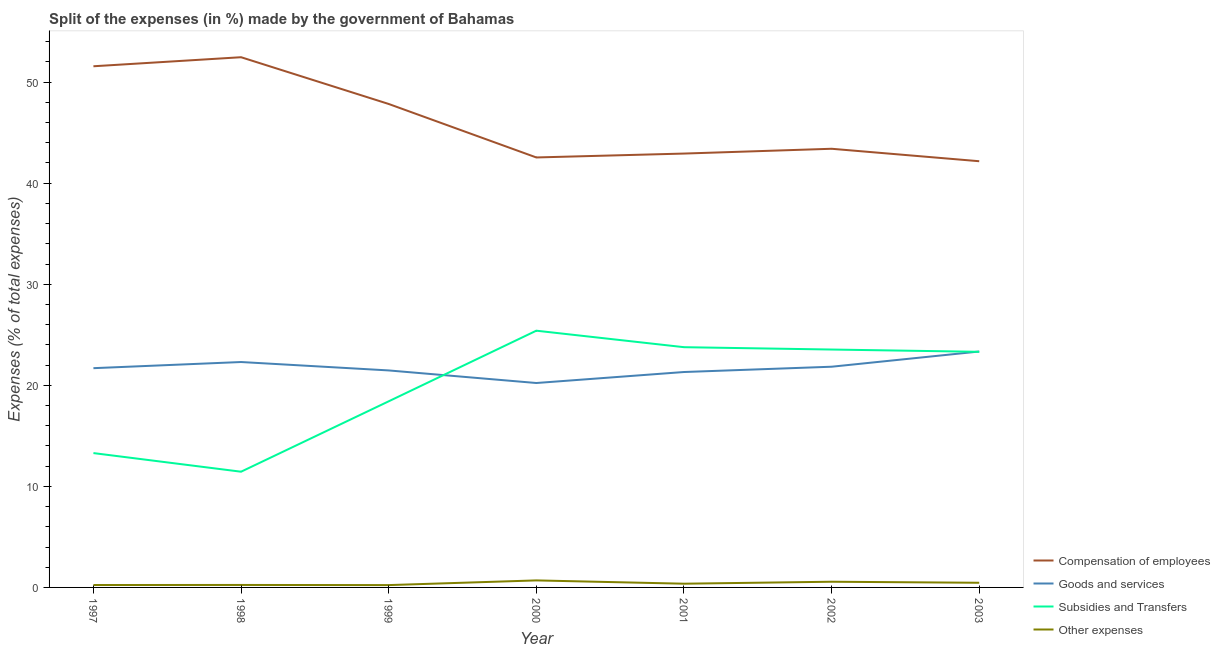Does the line corresponding to percentage of amount spent on goods and services intersect with the line corresponding to percentage of amount spent on compensation of employees?
Your response must be concise. No. Is the number of lines equal to the number of legend labels?
Make the answer very short. Yes. What is the percentage of amount spent on compensation of employees in 2001?
Provide a short and direct response. 42.93. Across all years, what is the maximum percentage of amount spent on other expenses?
Provide a succinct answer. 0.7. Across all years, what is the minimum percentage of amount spent on compensation of employees?
Give a very brief answer. 42.17. In which year was the percentage of amount spent on compensation of employees minimum?
Keep it short and to the point. 2003. What is the total percentage of amount spent on goods and services in the graph?
Keep it short and to the point. 152.19. What is the difference between the percentage of amount spent on goods and services in 1997 and that in 2000?
Provide a succinct answer. 1.47. What is the difference between the percentage of amount spent on goods and services in 2001 and the percentage of amount spent on subsidies in 2003?
Your answer should be very brief. -2. What is the average percentage of amount spent on goods and services per year?
Your answer should be very brief. 21.74. In the year 2002, what is the difference between the percentage of amount spent on compensation of employees and percentage of amount spent on subsidies?
Keep it short and to the point. 19.87. What is the ratio of the percentage of amount spent on goods and services in 1997 to that in 1998?
Offer a terse response. 0.97. Is the percentage of amount spent on compensation of employees in 2001 less than that in 2002?
Your answer should be compact. Yes. What is the difference between the highest and the second highest percentage of amount spent on compensation of employees?
Provide a succinct answer. 0.9. What is the difference between the highest and the lowest percentage of amount spent on goods and services?
Your answer should be very brief. 3.12. In how many years, is the percentage of amount spent on compensation of employees greater than the average percentage of amount spent on compensation of employees taken over all years?
Make the answer very short. 3. Is the sum of the percentage of amount spent on subsidies in 1997 and 1998 greater than the maximum percentage of amount spent on other expenses across all years?
Your answer should be compact. Yes. Is it the case that in every year, the sum of the percentage of amount spent on compensation of employees and percentage of amount spent on goods and services is greater than the percentage of amount spent on subsidies?
Your answer should be very brief. Yes. How many lines are there?
Keep it short and to the point. 4. What is the difference between two consecutive major ticks on the Y-axis?
Give a very brief answer. 10. Does the graph contain any zero values?
Your answer should be compact. No. Does the graph contain grids?
Make the answer very short. No. How many legend labels are there?
Ensure brevity in your answer.  4. How are the legend labels stacked?
Your answer should be very brief. Vertical. What is the title of the graph?
Provide a short and direct response. Split of the expenses (in %) made by the government of Bahamas. What is the label or title of the Y-axis?
Give a very brief answer. Expenses (% of total expenses). What is the Expenses (% of total expenses) in Compensation of employees in 1997?
Keep it short and to the point. 51.57. What is the Expenses (% of total expenses) in Goods and services in 1997?
Make the answer very short. 21.7. What is the Expenses (% of total expenses) of Subsidies and Transfers in 1997?
Your answer should be very brief. 13.29. What is the Expenses (% of total expenses) in Other expenses in 1997?
Provide a short and direct response. 0.24. What is the Expenses (% of total expenses) of Compensation of employees in 1998?
Keep it short and to the point. 52.46. What is the Expenses (% of total expenses) in Goods and services in 1998?
Make the answer very short. 22.3. What is the Expenses (% of total expenses) in Subsidies and Transfers in 1998?
Offer a terse response. 11.45. What is the Expenses (% of total expenses) of Other expenses in 1998?
Keep it short and to the point. 0.25. What is the Expenses (% of total expenses) of Compensation of employees in 1999?
Your answer should be very brief. 47.84. What is the Expenses (% of total expenses) in Goods and services in 1999?
Keep it short and to the point. 21.47. What is the Expenses (% of total expenses) of Subsidies and Transfers in 1999?
Provide a short and direct response. 18.42. What is the Expenses (% of total expenses) in Other expenses in 1999?
Offer a very short reply. 0.23. What is the Expenses (% of total expenses) in Compensation of employees in 2000?
Ensure brevity in your answer.  42.55. What is the Expenses (% of total expenses) in Goods and services in 2000?
Your answer should be compact. 20.23. What is the Expenses (% of total expenses) in Subsidies and Transfers in 2000?
Your answer should be very brief. 25.4. What is the Expenses (% of total expenses) of Other expenses in 2000?
Provide a succinct answer. 0.7. What is the Expenses (% of total expenses) in Compensation of employees in 2001?
Provide a short and direct response. 42.93. What is the Expenses (% of total expenses) in Goods and services in 2001?
Provide a short and direct response. 21.31. What is the Expenses (% of total expenses) in Subsidies and Transfers in 2001?
Your answer should be compact. 23.77. What is the Expenses (% of total expenses) in Other expenses in 2001?
Your answer should be compact. 0.37. What is the Expenses (% of total expenses) of Compensation of employees in 2002?
Provide a short and direct response. 43.41. What is the Expenses (% of total expenses) in Goods and services in 2002?
Your answer should be very brief. 21.84. What is the Expenses (% of total expenses) of Subsidies and Transfers in 2002?
Provide a succinct answer. 23.54. What is the Expenses (% of total expenses) in Other expenses in 2002?
Offer a terse response. 0.56. What is the Expenses (% of total expenses) of Compensation of employees in 2003?
Make the answer very short. 42.17. What is the Expenses (% of total expenses) in Goods and services in 2003?
Offer a terse response. 23.34. What is the Expenses (% of total expenses) in Subsidies and Transfers in 2003?
Your answer should be compact. 23.31. What is the Expenses (% of total expenses) of Other expenses in 2003?
Your response must be concise. 0.46. Across all years, what is the maximum Expenses (% of total expenses) in Compensation of employees?
Your answer should be very brief. 52.46. Across all years, what is the maximum Expenses (% of total expenses) of Goods and services?
Your answer should be compact. 23.34. Across all years, what is the maximum Expenses (% of total expenses) of Subsidies and Transfers?
Provide a short and direct response. 25.4. Across all years, what is the maximum Expenses (% of total expenses) of Other expenses?
Ensure brevity in your answer.  0.7. Across all years, what is the minimum Expenses (% of total expenses) of Compensation of employees?
Offer a terse response. 42.17. Across all years, what is the minimum Expenses (% of total expenses) in Goods and services?
Provide a succinct answer. 20.23. Across all years, what is the minimum Expenses (% of total expenses) of Subsidies and Transfers?
Offer a very short reply. 11.45. Across all years, what is the minimum Expenses (% of total expenses) in Other expenses?
Your answer should be very brief. 0.23. What is the total Expenses (% of total expenses) of Compensation of employees in the graph?
Keep it short and to the point. 322.92. What is the total Expenses (% of total expenses) of Goods and services in the graph?
Make the answer very short. 152.19. What is the total Expenses (% of total expenses) of Subsidies and Transfers in the graph?
Provide a short and direct response. 139.19. What is the total Expenses (% of total expenses) of Other expenses in the graph?
Your answer should be very brief. 2.8. What is the difference between the Expenses (% of total expenses) in Compensation of employees in 1997 and that in 1998?
Provide a short and direct response. -0.9. What is the difference between the Expenses (% of total expenses) in Goods and services in 1997 and that in 1998?
Offer a terse response. -0.61. What is the difference between the Expenses (% of total expenses) in Subsidies and Transfers in 1997 and that in 1998?
Provide a short and direct response. 1.84. What is the difference between the Expenses (% of total expenses) in Other expenses in 1997 and that in 1998?
Your answer should be very brief. -0.01. What is the difference between the Expenses (% of total expenses) in Compensation of employees in 1997 and that in 1999?
Give a very brief answer. 3.73. What is the difference between the Expenses (% of total expenses) of Goods and services in 1997 and that in 1999?
Your response must be concise. 0.22. What is the difference between the Expenses (% of total expenses) in Subsidies and Transfers in 1997 and that in 1999?
Your answer should be compact. -5.12. What is the difference between the Expenses (% of total expenses) of Other expenses in 1997 and that in 1999?
Provide a short and direct response. 0.01. What is the difference between the Expenses (% of total expenses) of Compensation of employees in 1997 and that in 2000?
Offer a terse response. 9.02. What is the difference between the Expenses (% of total expenses) of Goods and services in 1997 and that in 2000?
Your response must be concise. 1.47. What is the difference between the Expenses (% of total expenses) of Subsidies and Transfers in 1997 and that in 2000?
Ensure brevity in your answer.  -12.11. What is the difference between the Expenses (% of total expenses) of Other expenses in 1997 and that in 2000?
Provide a succinct answer. -0.46. What is the difference between the Expenses (% of total expenses) of Compensation of employees in 1997 and that in 2001?
Offer a terse response. 8.64. What is the difference between the Expenses (% of total expenses) in Goods and services in 1997 and that in 2001?
Provide a short and direct response. 0.38. What is the difference between the Expenses (% of total expenses) in Subsidies and Transfers in 1997 and that in 2001?
Make the answer very short. -10.48. What is the difference between the Expenses (% of total expenses) in Other expenses in 1997 and that in 2001?
Make the answer very short. -0.13. What is the difference between the Expenses (% of total expenses) in Compensation of employees in 1997 and that in 2002?
Keep it short and to the point. 8.16. What is the difference between the Expenses (% of total expenses) of Goods and services in 1997 and that in 2002?
Give a very brief answer. -0.14. What is the difference between the Expenses (% of total expenses) in Subsidies and Transfers in 1997 and that in 2002?
Your response must be concise. -10.25. What is the difference between the Expenses (% of total expenses) of Other expenses in 1997 and that in 2002?
Keep it short and to the point. -0.32. What is the difference between the Expenses (% of total expenses) in Compensation of employees in 1997 and that in 2003?
Provide a succinct answer. 9.4. What is the difference between the Expenses (% of total expenses) of Goods and services in 1997 and that in 2003?
Make the answer very short. -1.65. What is the difference between the Expenses (% of total expenses) in Subsidies and Transfers in 1997 and that in 2003?
Provide a succinct answer. -10.02. What is the difference between the Expenses (% of total expenses) in Other expenses in 1997 and that in 2003?
Offer a very short reply. -0.22. What is the difference between the Expenses (% of total expenses) in Compensation of employees in 1998 and that in 1999?
Provide a succinct answer. 4.63. What is the difference between the Expenses (% of total expenses) of Goods and services in 1998 and that in 1999?
Give a very brief answer. 0.83. What is the difference between the Expenses (% of total expenses) of Subsidies and Transfers in 1998 and that in 1999?
Provide a short and direct response. -6.97. What is the difference between the Expenses (% of total expenses) in Other expenses in 1998 and that in 1999?
Provide a short and direct response. 0.01. What is the difference between the Expenses (% of total expenses) in Compensation of employees in 1998 and that in 2000?
Keep it short and to the point. 9.92. What is the difference between the Expenses (% of total expenses) of Goods and services in 1998 and that in 2000?
Keep it short and to the point. 2.08. What is the difference between the Expenses (% of total expenses) of Subsidies and Transfers in 1998 and that in 2000?
Offer a terse response. -13.95. What is the difference between the Expenses (% of total expenses) in Other expenses in 1998 and that in 2000?
Keep it short and to the point. -0.45. What is the difference between the Expenses (% of total expenses) of Compensation of employees in 1998 and that in 2001?
Make the answer very short. 9.53. What is the difference between the Expenses (% of total expenses) in Goods and services in 1998 and that in 2001?
Give a very brief answer. 0.99. What is the difference between the Expenses (% of total expenses) of Subsidies and Transfers in 1998 and that in 2001?
Ensure brevity in your answer.  -12.32. What is the difference between the Expenses (% of total expenses) in Other expenses in 1998 and that in 2001?
Offer a terse response. -0.12. What is the difference between the Expenses (% of total expenses) of Compensation of employees in 1998 and that in 2002?
Give a very brief answer. 9.06. What is the difference between the Expenses (% of total expenses) of Goods and services in 1998 and that in 2002?
Offer a terse response. 0.47. What is the difference between the Expenses (% of total expenses) in Subsidies and Transfers in 1998 and that in 2002?
Your answer should be very brief. -12.09. What is the difference between the Expenses (% of total expenses) of Other expenses in 1998 and that in 2002?
Ensure brevity in your answer.  -0.32. What is the difference between the Expenses (% of total expenses) of Compensation of employees in 1998 and that in 2003?
Your response must be concise. 10.29. What is the difference between the Expenses (% of total expenses) in Goods and services in 1998 and that in 2003?
Offer a very short reply. -1.04. What is the difference between the Expenses (% of total expenses) of Subsidies and Transfers in 1998 and that in 2003?
Your answer should be very brief. -11.86. What is the difference between the Expenses (% of total expenses) of Other expenses in 1998 and that in 2003?
Keep it short and to the point. -0.22. What is the difference between the Expenses (% of total expenses) of Compensation of employees in 1999 and that in 2000?
Your response must be concise. 5.29. What is the difference between the Expenses (% of total expenses) of Goods and services in 1999 and that in 2000?
Make the answer very short. 1.24. What is the difference between the Expenses (% of total expenses) of Subsidies and Transfers in 1999 and that in 2000?
Your response must be concise. -6.99. What is the difference between the Expenses (% of total expenses) in Other expenses in 1999 and that in 2000?
Provide a succinct answer. -0.46. What is the difference between the Expenses (% of total expenses) of Compensation of employees in 1999 and that in 2001?
Your answer should be compact. 4.91. What is the difference between the Expenses (% of total expenses) of Goods and services in 1999 and that in 2001?
Offer a terse response. 0.16. What is the difference between the Expenses (% of total expenses) of Subsidies and Transfers in 1999 and that in 2001?
Provide a succinct answer. -5.36. What is the difference between the Expenses (% of total expenses) in Other expenses in 1999 and that in 2001?
Ensure brevity in your answer.  -0.14. What is the difference between the Expenses (% of total expenses) in Compensation of employees in 1999 and that in 2002?
Your answer should be very brief. 4.43. What is the difference between the Expenses (% of total expenses) in Goods and services in 1999 and that in 2002?
Provide a succinct answer. -0.37. What is the difference between the Expenses (% of total expenses) in Subsidies and Transfers in 1999 and that in 2002?
Offer a very short reply. -5.12. What is the difference between the Expenses (% of total expenses) in Other expenses in 1999 and that in 2002?
Ensure brevity in your answer.  -0.33. What is the difference between the Expenses (% of total expenses) in Compensation of employees in 1999 and that in 2003?
Keep it short and to the point. 5.67. What is the difference between the Expenses (% of total expenses) in Goods and services in 1999 and that in 2003?
Give a very brief answer. -1.87. What is the difference between the Expenses (% of total expenses) of Subsidies and Transfers in 1999 and that in 2003?
Give a very brief answer. -4.9. What is the difference between the Expenses (% of total expenses) of Other expenses in 1999 and that in 2003?
Keep it short and to the point. -0.23. What is the difference between the Expenses (% of total expenses) in Compensation of employees in 2000 and that in 2001?
Make the answer very short. -0.38. What is the difference between the Expenses (% of total expenses) in Goods and services in 2000 and that in 2001?
Keep it short and to the point. -1.09. What is the difference between the Expenses (% of total expenses) in Subsidies and Transfers in 2000 and that in 2001?
Your answer should be compact. 1.63. What is the difference between the Expenses (% of total expenses) of Other expenses in 2000 and that in 2001?
Keep it short and to the point. 0.33. What is the difference between the Expenses (% of total expenses) in Compensation of employees in 2000 and that in 2002?
Your answer should be very brief. -0.86. What is the difference between the Expenses (% of total expenses) in Goods and services in 2000 and that in 2002?
Your response must be concise. -1.61. What is the difference between the Expenses (% of total expenses) of Subsidies and Transfers in 2000 and that in 2002?
Provide a succinct answer. 1.86. What is the difference between the Expenses (% of total expenses) in Other expenses in 2000 and that in 2002?
Make the answer very short. 0.13. What is the difference between the Expenses (% of total expenses) of Compensation of employees in 2000 and that in 2003?
Your answer should be very brief. 0.37. What is the difference between the Expenses (% of total expenses) of Goods and services in 2000 and that in 2003?
Give a very brief answer. -3.12. What is the difference between the Expenses (% of total expenses) of Subsidies and Transfers in 2000 and that in 2003?
Provide a succinct answer. 2.09. What is the difference between the Expenses (% of total expenses) of Other expenses in 2000 and that in 2003?
Give a very brief answer. 0.23. What is the difference between the Expenses (% of total expenses) in Compensation of employees in 2001 and that in 2002?
Your response must be concise. -0.48. What is the difference between the Expenses (% of total expenses) of Goods and services in 2001 and that in 2002?
Keep it short and to the point. -0.52. What is the difference between the Expenses (% of total expenses) in Subsidies and Transfers in 2001 and that in 2002?
Give a very brief answer. 0.23. What is the difference between the Expenses (% of total expenses) of Other expenses in 2001 and that in 2002?
Your answer should be compact. -0.19. What is the difference between the Expenses (% of total expenses) of Compensation of employees in 2001 and that in 2003?
Your answer should be compact. 0.76. What is the difference between the Expenses (% of total expenses) of Goods and services in 2001 and that in 2003?
Your response must be concise. -2.03. What is the difference between the Expenses (% of total expenses) in Subsidies and Transfers in 2001 and that in 2003?
Ensure brevity in your answer.  0.46. What is the difference between the Expenses (% of total expenses) of Other expenses in 2001 and that in 2003?
Give a very brief answer. -0.09. What is the difference between the Expenses (% of total expenses) in Compensation of employees in 2002 and that in 2003?
Keep it short and to the point. 1.23. What is the difference between the Expenses (% of total expenses) of Goods and services in 2002 and that in 2003?
Give a very brief answer. -1.51. What is the difference between the Expenses (% of total expenses) of Subsidies and Transfers in 2002 and that in 2003?
Make the answer very short. 0.23. What is the difference between the Expenses (% of total expenses) in Other expenses in 2002 and that in 2003?
Provide a short and direct response. 0.1. What is the difference between the Expenses (% of total expenses) in Compensation of employees in 1997 and the Expenses (% of total expenses) in Goods and services in 1998?
Offer a very short reply. 29.26. What is the difference between the Expenses (% of total expenses) in Compensation of employees in 1997 and the Expenses (% of total expenses) in Subsidies and Transfers in 1998?
Ensure brevity in your answer.  40.12. What is the difference between the Expenses (% of total expenses) of Compensation of employees in 1997 and the Expenses (% of total expenses) of Other expenses in 1998?
Your answer should be compact. 51.32. What is the difference between the Expenses (% of total expenses) of Goods and services in 1997 and the Expenses (% of total expenses) of Subsidies and Transfers in 1998?
Keep it short and to the point. 10.24. What is the difference between the Expenses (% of total expenses) of Goods and services in 1997 and the Expenses (% of total expenses) of Other expenses in 1998?
Your answer should be very brief. 21.45. What is the difference between the Expenses (% of total expenses) of Subsidies and Transfers in 1997 and the Expenses (% of total expenses) of Other expenses in 1998?
Offer a very short reply. 13.05. What is the difference between the Expenses (% of total expenses) in Compensation of employees in 1997 and the Expenses (% of total expenses) in Goods and services in 1999?
Keep it short and to the point. 30.1. What is the difference between the Expenses (% of total expenses) of Compensation of employees in 1997 and the Expenses (% of total expenses) of Subsidies and Transfers in 1999?
Ensure brevity in your answer.  33.15. What is the difference between the Expenses (% of total expenses) of Compensation of employees in 1997 and the Expenses (% of total expenses) of Other expenses in 1999?
Ensure brevity in your answer.  51.34. What is the difference between the Expenses (% of total expenses) of Goods and services in 1997 and the Expenses (% of total expenses) of Subsidies and Transfers in 1999?
Offer a very short reply. 3.28. What is the difference between the Expenses (% of total expenses) of Goods and services in 1997 and the Expenses (% of total expenses) of Other expenses in 1999?
Ensure brevity in your answer.  21.46. What is the difference between the Expenses (% of total expenses) of Subsidies and Transfers in 1997 and the Expenses (% of total expenses) of Other expenses in 1999?
Your answer should be very brief. 13.06. What is the difference between the Expenses (% of total expenses) of Compensation of employees in 1997 and the Expenses (% of total expenses) of Goods and services in 2000?
Your answer should be very brief. 31.34. What is the difference between the Expenses (% of total expenses) in Compensation of employees in 1997 and the Expenses (% of total expenses) in Subsidies and Transfers in 2000?
Keep it short and to the point. 26.16. What is the difference between the Expenses (% of total expenses) of Compensation of employees in 1997 and the Expenses (% of total expenses) of Other expenses in 2000?
Keep it short and to the point. 50.87. What is the difference between the Expenses (% of total expenses) of Goods and services in 1997 and the Expenses (% of total expenses) of Subsidies and Transfers in 2000?
Offer a terse response. -3.71. What is the difference between the Expenses (% of total expenses) of Goods and services in 1997 and the Expenses (% of total expenses) of Other expenses in 2000?
Your answer should be compact. 21. What is the difference between the Expenses (% of total expenses) in Subsidies and Transfers in 1997 and the Expenses (% of total expenses) in Other expenses in 2000?
Keep it short and to the point. 12.6. What is the difference between the Expenses (% of total expenses) in Compensation of employees in 1997 and the Expenses (% of total expenses) in Goods and services in 2001?
Your answer should be compact. 30.25. What is the difference between the Expenses (% of total expenses) in Compensation of employees in 1997 and the Expenses (% of total expenses) in Subsidies and Transfers in 2001?
Offer a very short reply. 27.8. What is the difference between the Expenses (% of total expenses) in Compensation of employees in 1997 and the Expenses (% of total expenses) in Other expenses in 2001?
Provide a succinct answer. 51.2. What is the difference between the Expenses (% of total expenses) in Goods and services in 1997 and the Expenses (% of total expenses) in Subsidies and Transfers in 2001?
Give a very brief answer. -2.08. What is the difference between the Expenses (% of total expenses) of Goods and services in 1997 and the Expenses (% of total expenses) of Other expenses in 2001?
Provide a short and direct response. 21.33. What is the difference between the Expenses (% of total expenses) of Subsidies and Transfers in 1997 and the Expenses (% of total expenses) of Other expenses in 2001?
Your response must be concise. 12.92. What is the difference between the Expenses (% of total expenses) in Compensation of employees in 1997 and the Expenses (% of total expenses) in Goods and services in 2002?
Your answer should be compact. 29.73. What is the difference between the Expenses (% of total expenses) of Compensation of employees in 1997 and the Expenses (% of total expenses) of Subsidies and Transfers in 2002?
Your answer should be very brief. 28.03. What is the difference between the Expenses (% of total expenses) in Compensation of employees in 1997 and the Expenses (% of total expenses) in Other expenses in 2002?
Give a very brief answer. 51. What is the difference between the Expenses (% of total expenses) of Goods and services in 1997 and the Expenses (% of total expenses) of Subsidies and Transfers in 2002?
Your answer should be compact. -1.84. What is the difference between the Expenses (% of total expenses) of Goods and services in 1997 and the Expenses (% of total expenses) of Other expenses in 2002?
Offer a very short reply. 21.13. What is the difference between the Expenses (% of total expenses) in Subsidies and Transfers in 1997 and the Expenses (% of total expenses) in Other expenses in 2002?
Ensure brevity in your answer.  12.73. What is the difference between the Expenses (% of total expenses) of Compensation of employees in 1997 and the Expenses (% of total expenses) of Goods and services in 2003?
Offer a very short reply. 28.22. What is the difference between the Expenses (% of total expenses) in Compensation of employees in 1997 and the Expenses (% of total expenses) in Subsidies and Transfers in 2003?
Your answer should be very brief. 28.25. What is the difference between the Expenses (% of total expenses) in Compensation of employees in 1997 and the Expenses (% of total expenses) in Other expenses in 2003?
Offer a terse response. 51.11. What is the difference between the Expenses (% of total expenses) in Goods and services in 1997 and the Expenses (% of total expenses) in Subsidies and Transfers in 2003?
Keep it short and to the point. -1.62. What is the difference between the Expenses (% of total expenses) of Goods and services in 1997 and the Expenses (% of total expenses) of Other expenses in 2003?
Your response must be concise. 21.23. What is the difference between the Expenses (% of total expenses) in Subsidies and Transfers in 1997 and the Expenses (% of total expenses) in Other expenses in 2003?
Provide a short and direct response. 12.83. What is the difference between the Expenses (% of total expenses) of Compensation of employees in 1998 and the Expenses (% of total expenses) of Goods and services in 1999?
Keep it short and to the point. 30.99. What is the difference between the Expenses (% of total expenses) in Compensation of employees in 1998 and the Expenses (% of total expenses) in Subsidies and Transfers in 1999?
Your answer should be compact. 34.05. What is the difference between the Expenses (% of total expenses) in Compensation of employees in 1998 and the Expenses (% of total expenses) in Other expenses in 1999?
Offer a terse response. 52.23. What is the difference between the Expenses (% of total expenses) of Goods and services in 1998 and the Expenses (% of total expenses) of Subsidies and Transfers in 1999?
Keep it short and to the point. 3.89. What is the difference between the Expenses (% of total expenses) of Goods and services in 1998 and the Expenses (% of total expenses) of Other expenses in 1999?
Give a very brief answer. 22.07. What is the difference between the Expenses (% of total expenses) of Subsidies and Transfers in 1998 and the Expenses (% of total expenses) of Other expenses in 1999?
Ensure brevity in your answer.  11.22. What is the difference between the Expenses (% of total expenses) in Compensation of employees in 1998 and the Expenses (% of total expenses) in Goods and services in 2000?
Provide a succinct answer. 32.24. What is the difference between the Expenses (% of total expenses) of Compensation of employees in 1998 and the Expenses (% of total expenses) of Subsidies and Transfers in 2000?
Offer a very short reply. 27.06. What is the difference between the Expenses (% of total expenses) in Compensation of employees in 1998 and the Expenses (% of total expenses) in Other expenses in 2000?
Your response must be concise. 51.77. What is the difference between the Expenses (% of total expenses) in Goods and services in 1998 and the Expenses (% of total expenses) in Subsidies and Transfers in 2000?
Keep it short and to the point. -3.1. What is the difference between the Expenses (% of total expenses) in Goods and services in 1998 and the Expenses (% of total expenses) in Other expenses in 2000?
Ensure brevity in your answer.  21.61. What is the difference between the Expenses (% of total expenses) of Subsidies and Transfers in 1998 and the Expenses (% of total expenses) of Other expenses in 2000?
Your answer should be compact. 10.76. What is the difference between the Expenses (% of total expenses) of Compensation of employees in 1998 and the Expenses (% of total expenses) of Goods and services in 2001?
Ensure brevity in your answer.  31.15. What is the difference between the Expenses (% of total expenses) in Compensation of employees in 1998 and the Expenses (% of total expenses) in Subsidies and Transfers in 2001?
Give a very brief answer. 28.69. What is the difference between the Expenses (% of total expenses) of Compensation of employees in 1998 and the Expenses (% of total expenses) of Other expenses in 2001?
Offer a terse response. 52.09. What is the difference between the Expenses (% of total expenses) of Goods and services in 1998 and the Expenses (% of total expenses) of Subsidies and Transfers in 2001?
Offer a terse response. -1.47. What is the difference between the Expenses (% of total expenses) in Goods and services in 1998 and the Expenses (% of total expenses) in Other expenses in 2001?
Keep it short and to the point. 21.93. What is the difference between the Expenses (% of total expenses) of Subsidies and Transfers in 1998 and the Expenses (% of total expenses) of Other expenses in 2001?
Give a very brief answer. 11.08. What is the difference between the Expenses (% of total expenses) in Compensation of employees in 1998 and the Expenses (% of total expenses) in Goods and services in 2002?
Keep it short and to the point. 30.63. What is the difference between the Expenses (% of total expenses) of Compensation of employees in 1998 and the Expenses (% of total expenses) of Subsidies and Transfers in 2002?
Offer a very short reply. 28.92. What is the difference between the Expenses (% of total expenses) of Compensation of employees in 1998 and the Expenses (% of total expenses) of Other expenses in 2002?
Your answer should be very brief. 51.9. What is the difference between the Expenses (% of total expenses) of Goods and services in 1998 and the Expenses (% of total expenses) of Subsidies and Transfers in 2002?
Make the answer very short. -1.24. What is the difference between the Expenses (% of total expenses) of Goods and services in 1998 and the Expenses (% of total expenses) of Other expenses in 2002?
Offer a very short reply. 21.74. What is the difference between the Expenses (% of total expenses) in Subsidies and Transfers in 1998 and the Expenses (% of total expenses) in Other expenses in 2002?
Your answer should be compact. 10.89. What is the difference between the Expenses (% of total expenses) in Compensation of employees in 1998 and the Expenses (% of total expenses) in Goods and services in 2003?
Make the answer very short. 29.12. What is the difference between the Expenses (% of total expenses) of Compensation of employees in 1998 and the Expenses (% of total expenses) of Subsidies and Transfers in 2003?
Your answer should be very brief. 29.15. What is the difference between the Expenses (% of total expenses) of Compensation of employees in 1998 and the Expenses (% of total expenses) of Other expenses in 2003?
Provide a short and direct response. 52. What is the difference between the Expenses (% of total expenses) of Goods and services in 1998 and the Expenses (% of total expenses) of Subsidies and Transfers in 2003?
Provide a short and direct response. -1.01. What is the difference between the Expenses (% of total expenses) in Goods and services in 1998 and the Expenses (% of total expenses) in Other expenses in 2003?
Ensure brevity in your answer.  21.84. What is the difference between the Expenses (% of total expenses) in Subsidies and Transfers in 1998 and the Expenses (% of total expenses) in Other expenses in 2003?
Keep it short and to the point. 10.99. What is the difference between the Expenses (% of total expenses) of Compensation of employees in 1999 and the Expenses (% of total expenses) of Goods and services in 2000?
Keep it short and to the point. 27.61. What is the difference between the Expenses (% of total expenses) in Compensation of employees in 1999 and the Expenses (% of total expenses) in Subsidies and Transfers in 2000?
Offer a terse response. 22.43. What is the difference between the Expenses (% of total expenses) of Compensation of employees in 1999 and the Expenses (% of total expenses) of Other expenses in 2000?
Offer a terse response. 47.14. What is the difference between the Expenses (% of total expenses) in Goods and services in 1999 and the Expenses (% of total expenses) in Subsidies and Transfers in 2000?
Your answer should be very brief. -3.93. What is the difference between the Expenses (% of total expenses) in Goods and services in 1999 and the Expenses (% of total expenses) in Other expenses in 2000?
Your answer should be very brief. 20.78. What is the difference between the Expenses (% of total expenses) of Subsidies and Transfers in 1999 and the Expenses (% of total expenses) of Other expenses in 2000?
Ensure brevity in your answer.  17.72. What is the difference between the Expenses (% of total expenses) in Compensation of employees in 1999 and the Expenses (% of total expenses) in Goods and services in 2001?
Provide a short and direct response. 26.52. What is the difference between the Expenses (% of total expenses) of Compensation of employees in 1999 and the Expenses (% of total expenses) of Subsidies and Transfers in 2001?
Keep it short and to the point. 24.07. What is the difference between the Expenses (% of total expenses) of Compensation of employees in 1999 and the Expenses (% of total expenses) of Other expenses in 2001?
Your answer should be compact. 47.47. What is the difference between the Expenses (% of total expenses) in Goods and services in 1999 and the Expenses (% of total expenses) in Subsidies and Transfers in 2001?
Give a very brief answer. -2.3. What is the difference between the Expenses (% of total expenses) of Goods and services in 1999 and the Expenses (% of total expenses) of Other expenses in 2001?
Offer a terse response. 21.1. What is the difference between the Expenses (% of total expenses) in Subsidies and Transfers in 1999 and the Expenses (% of total expenses) in Other expenses in 2001?
Offer a very short reply. 18.05. What is the difference between the Expenses (% of total expenses) in Compensation of employees in 1999 and the Expenses (% of total expenses) in Goods and services in 2002?
Your response must be concise. 26. What is the difference between the Expenses (% of total expenses) of Compensation of employees in 1999 and the Expenses (% of total expenses) of Subsidies and Transfers in 2002?
Your response must be concise. 24.3. What is the difference between the Expenses (% of total expenses) in Compensation of employees in 1999 and the Expenses (% of total expenses) in Other expenses in 2002?
Offer a very short reply. 47.27. What is the difference between the Expenses (% of total expenses) in Goods and services in 1999 and the Expenses (% of total expenses) in Subsidies and Transfers in 2002?
Make the answer very short. -2.07. What is the difference between the Expenses (% of total expenses) in Goods and services in 1999 and the Expenses (% of total expenses) in Other expenses in 2002?
Offer a very short reply. 20.91. What is the difference between the Expenses (% of total expenses) of Subsidies and Transfers in 1999 and the Expenses (% of total expenses) of Other expenses in 2002?
Make the answer very short. 17.85. What is the difference between the Expenses (% of total expenses) in Compensation of employees in 1999 and the Expenses (% of total expenses) in Goods and services in 2003?
Provide a short and direct response. 24.49. What is the difference between the Expenses (% of total expenses) in Compensation of employees in 1999 and the Expenses (% of total expenses) in Subsidies and Transfers in 2003?
Give a very brief answer. 24.52. What is the difference between the Expenses (% of total expenses) of Compensation of employees in 1999 and the Expenses (% of total expenses) of Other expenses in 2003?
Keep it short and to the point. 47.38. What is the difference between the Expenses (% of total expenses) in Goods and services in 1999 and the Expenses (% of total expenses) in Subsidies and Transfers in 2003?
Ensure brevity in your answer.  -1.84. What is the difference between the Expenses (% of total expenses) of Goods and services in 1999 and the Expenses (% of total expenses) of Other expenses in 2003?
Keep it short and to the point. 21.01. What is the difference between the Expenses (% of total expenses) in Subsidies and Transfers in 1999 and the Expenses (% of total expenses) in Other expenses in 2003?
Give a very brief answer. 17.96. What is the difference between the Expenses (% of total expenses) of Compensation of employees in 2000 and the Expenses (% of total expenses) of Goods and services in 2001?
Your answer should be very brief. 21.23. What is the difference between the Expenses (% of total expenses) of Compensation of employees in 2000 and the Expenses (% of total expenses) of Subsidies and Transfers in 2001?
Offer a very short reply. 18.77. What is the difference between the Expenses (% of total expenses) of Compensation of employees in 2000 and the Expenses (% of total expenses) of Other expenses in 2001?
Keep it short and to the point. 42.18. What is the difference between the Expenses (% of total expenses) in Goods and services in 2000 and the Expenses (% of total expenses) in Subsidies and Transfers in 2001?
Your answer should be very brief. -3.54. What is the difference between the Expenses (% of total expenses) of Goods and services in 2000 and the Expenses (% of total expenses) of Other expenses in 2001?
Offer a terse response. 19.86. What is the difference between the Expenses (% of total expenses) of Subsidies and Transfers in 2000 and the Expenses (% of total expenses) of Other expenses in 2001?
Give a very brief answer. 25.03. What is the difference between the Expenses (% of total expenses) in Compensation of employees in 2000 and the Expenses (% of total expenses) in Goods and services in 2002?
Provide a succinct answer. 20.71. What is the difference between the Expenses (% of total expenses) of Compensation of employees in 2000 and the Expenses (% of total expenses) of Subsidies and Transfers in 2002?
Offer a very short reply. 19.01. What is the difference between the Expenses (% of total expenses) in Compensation of employees in 2000 and the Expenses (% of total expenses) in Other expenses in 2002?
Your answer should be very brief. 41.98. What is the difference between the Expenses (% of total expenses) in Goods and services in 2000 and the Expenses (% of total expenses) in Subsidies and Transfers in 2002?
Your response must be concise. -3.31. What is the difference between the Expenses (% of total expenses) in Goods and services in 2000 and the Expenses (% of total expenses) in Other expenses in 2002?
Your answer should be compact. 19.66. What is the difference between the Expenses (% of total expenses) of Subsidies and Transfers in 2000 and the Expenses (% of total expenses) of Other expenses in 2002?
Provide a succinct answer. 24.84. What is the difference between the Expenses (% of total expenses) in Compensation of employees in 2000 and the Expenses (% of total expenses) in Goods and services in 2003?
Provide a succinct answer. 19.2. What is the difference between the Expenses (% of total expenses) of Compensation of employees in 2000 and the Expenses (% of total expenses) of Subsidies and Transfers in 2003?
Make the answer very short. 19.23. What is the difference between the Expenses (% of total expenses) in Compensation of employees in 2000 and the Expenses (% of total expenses) in Other expenses in 2003?
Your response must be concise. 42.08. What is the difference between the Expenses (% of total expenses) of Goods and services in 2000 and the Expenses (% of total expenses) of Subsidies and Transfers in 2003?
Provide a succinct answer. -3.09. What is the difference between the Expenses (% of total expenses) in Goods and services in 2000 and the Expenses (% of total expenses) in Other expenses in 2003?
Make the answer very short. 19.77. What is the difference between the Expenses (% of total expenses) of Subsidies and Transfers in 2000 and the Expenses (% of total expenses) of Other expenses in 2003?
Your response must be concise. 24.94. What is the difference between the Expenses (% of total expenses) of Compensation of employees in 2001 and the Expenses (% of total expenses) of Goods and services in 2002?
Provide a succinct answer. 21.09. What is the difference between the Expenses (% of total expenses) in Compensation of employees in 2001 and the Expenses (% of total expenses) in Subsidies and Transfers in 2002?
Keep it short and to the point. 19.39. What is the difference between the Expenses (% of total expenses) in Compensation of employees in 2001 and the Expenses (% of total expenses) in Other expenses in 2002?
Offer a terse response. 42.37. What is the difference between the Expenses (% of total expenses) of Goods and services in 2001 and the Expenses (% of total expenses) of Subsidies and Transfers in 2002?
Keep it short and to the point. -2.22. What is the difference between the Expenses (% of total expenses) of Goods and services in 2001 and the Expenses (% of total expenses) of Other expenses in 2002?
Make the answer very short. 20.75. What is the difference between the Expenses (% of total expenses) of Subsidies and Transfers in 2001 and the Expenses (% of total expenses) of Other expenses in 2002?
Offer a terse response. 23.21. What is the difference between the Expenses (% of total expenses) in Compensation of employees in 2001 and the Expenses (% of total expenses) in Goods and services in 2003?
Offer a very short reply. 19.59. What is the difference between the Expenses (% of total expenses) in Compensation of employees in 2001 and the Expenses (% of total expenses) in Subsidies and Transfers in 2003?
Keep it short and to the point. 19.62. What is the difference between the Expenses (% of total expenses) in Compensation of employees in 2001 and the Expenses (% of total expenses) in Other expenses in 2003?
Your response must be concise. 42.47. What is the difference between the Expenses (% of total expenses) of Goods and services in 2001 and the Expenses (% of total expenses) of Subsidies and Transfers in 2003?
Offer a very short reply. -2. What is the difference between the Expenses (% of total expenses) in Goods and services in 2001 and the Expenses (% of total expenses) in Other expenses in 2003?
Give a very brief answer. 20.85. What is the difference between the Expenses (% of total expenses) in Subsidies and Transfers in 2001 and the Expenses (% of total expenses) in Other expenses in 2003?
Keep it short and to the point. 23.31. What is the difference between the Expenses (% of total expenses) in Compensation of employees in 2002 and the Expenses (% of total expenses) in Goods and services in 2003?
Provide a succinct answer. 20.06. What is the difference between the Expenses (% of total expenses) of Compensation of employees in 2002 and the Expenses (% of total expenses) of Subsidies and Transfers in 2003?
Provide a short and direct response. 20.09. What is the difference between the Expenses (% of total expenses) of Compensation of employees in 2002 and the Expenses (% of total expenses) of Other expenses in 2003?
Your response must be concise. 42.94. What is the difference between the Expenses (% of total expenses) in Goods and services in 2002 and the Expenses (% of total expenses) in Subsidies and Transfers in 2003?
Provide a succinct answer. -1.48. What is the difference between the Expenses (% of total expenses) of Goods and services in 2002 and the Expenses (% of total expenses) of Other expenses in 2003?
Offer a very short reply. 21.38. What is the difference between the Expenses (% of total expenses) of Subsidies and Transfers in 2002 and the Expenses (% of total expenses) of Other expenses in 2003?
Provide a succinct answer. 23.08. What is the average Expenses (% of total expenses) in Compensation of employees per year?
Ensure brevity in your answer.  46.13. What is the average Expenses (% of total expenses) in Goods and services per year?
Offer a very short reply. 21.74. What is the average Expenses (% of total expenses) in Subsidies and Transfers per year?
Your response must be concise. 19.88. What is the average Expenses (% of total expenses) of Other expenses per year?
Your answer should be compact. 0.4. In the year 1997, what is the difference between the Expenses (% of total expenses) in Compensation of employees and Expenses (% of total expenses) in Goods and services?
Ensure brevity in your answer.  29.87. In the year 1997, what is the difference between the Expenses (% of total expenses) of Compensation of employees and Expenses (% of total expenses) of Subsidies and Transfers?
Your answer should be very brief. 38.28. In the year 1997, what is the difference between the Expenses (% of total expenses) of Compensation of employees and Expenses (% of total expenses) of Other expenses?
Your answer should be compact. 51.33. In the year 1997, what is the difference between the Expenses (% of total expenses) in Goods and services and Expenses (% of total expenses) in Subsidies and Transfers?
Offer a terse response. 8.4. In the year 1997, what is the difference between the Expenses (% of total expenses) in Goods and services and Expenses (% of total expenses) in Other expenses?
Ensure brevity in your answer.  21.46. In the year 1997, what is the difference between the Expenses (% of total expenses) of Subsidies and Transfers and Expenses (% of total expenses) of Other expenses?
Your answer should be compact. 13.05. In the year 1998, what is the difference between the Expenses (% of total expenses) in Compensation of employees and Expenses (% of total expenses) in Goods and services?
Ensure brevity in your answer.  30.16. In the year 1998, what is the difference between the Expenses (% of total expenses) of Compensation of employees and Expenses (% of total expenses) of Subsidies and Transfers?
Offer a terse response. 41.01. In the year 1998, what is the difference between the Expenses (% of total expenses) in Compensation of employees and Expenses (% of total expenses) in Other expenses?
Give a very brief answer. 52.22. In the year 1998, what is the difference between the Expenses (% of total expenses) in Goods and services and Expenses (% of total expenses) in Subsidies and Transfers?
Give a very brief answer. 10.85. In the year 1998, what is the difference between the Expenses (% of total expenses) in Goods and services and Expenses (% of total expenses) in Other expenses?
Provide a short and direct response. 22.06. In the year 1998, what is the difference between the Expenses (% of total expenses) in Subsidies and Transfers and Expenses (% of total expenses) in Other expenses?
Offer a very short reply. 11.21. In the year 1999, what is the difference between the Expenses (% of total expenses) of Compensation of employees and Expenses (% of total expenses) of Goods and services?
Your response must be concise. 26.37. In the year 1999, what is the difference between the Expenses (% of total expenses) of Compensation of employees and Expenses (% of total expenses) of Subsidies and Transfers?
Offer a terse response. 29.42. In the year 1999, what is the difference between the Expenses (% of total expenses) of Compensation of employees and Expenses (% of total expenses) of Other expenses?
Your response must be concise. 47.61. In the year 1999, what is the difference between the Expenses (% of total expenses) of Goods and services and Expenses (% of total expenses) of Subsidies and Transfers?
Offer a terse response. 3.06. In the year 1999, what is the difference between the Expenses (% of total expenses) in Goods and services and Expenses (% of total expenses) in Other expenses?
Ensure brevity in your answer.  21.24. In the year 1999, what is the difference between the Expenses (% of total expenses) of Subsidies and Transfers and Expenses (% of total expenses) of Other expenses?
Provide a succinct answer. 18.19. In the year 2000, what is the difference between the Expenses (% of total expenses) of Compensation of employees and Expenses (% of total expenses) of Goods and services?
Offer a very short reply. 22.32. In the year 2000, what is the difference between the Expenses (% of total expenses) of Compensation of employees and Expenses (% of total expenses) of Subsidies and Transfers?
Make the answer very short. 17.14. In the year 2000, what is the difference between the Expenses (% of total expenses) in Compensation of employees and Expenses (% of total expenses) in Other expenses?
Your response must be concise. 41.85. In the year 2000, what is the difference between the Expenses (% of total expenses) in Goods and services and Expenses (% of total expenses) in Subsidies and Transfers?
Offer a terse response. -5.18. In the year 2000, what is the difference between the Expenses (% of total expenses) of Goods and services and Expenses (% of total expenses) of Other expenses?
Your response must be concise. 19.53. In the year 2000, what is the difference between the Expenses (% of total expenses) of Subsidies and Transfers and Expenses (% of total expenses) of Other expenses?
Ensure brevity in your answer.  24.71. In the year 2001, what is the difference between the Expenses (% of total expenses) of Compensation of employees and Expenses (% of total expenses) of Goods and services?
Offer a terse response. 21.61. In the year 2001, what is the difference between the Expenses (% of total expenses) in Compensation of employees and Expenses (% of total expenses) in Subsidies and Transfers?
Keep it short and to the point. 19.16. In the year 2001, what is the difference between the Expenses (% of total expenses) of Compensation of employees and Expenses (% of total expenses) of Other expenses?
Your answer should be very brief. 42.56. In the year 2001, what is the difference between the Expenses (% of total expenses) of Goods and services and Expenses (% of total expenses) of Subsidies and Transfers?
Offer a terse response. -2.46. In the year 2001, what is the difference between the Expenses (% of total expenses) in Goods and services and Expenses (% of total expenses) in Other expenses?
Provide a short and direct response. 20.95. In the year 2001, what is the difference between the Expenses (% of total expenses) of Subsidies and Transfers and Expenses (% of total expenses) of Other expenses?
Your response must be concise. 23.4. In the year 2002, what is the difference between the Expenses (% of total expenses) in Compensation of employees and Expenses (% of total expenses) in Goods and services?
Your answer should be compact. 21.57. In the year 2002, what is the difference between the Expenses (% of total expenses) in Compensation of employees and Expenses (% of total expenses) in Subsidies and Transfers?
Offer a very short reply. 19.87. In the year 2002, what is the difference between the Expenses (% of total expenses) of Compensation of employees and Expenses (% of total expenses) of Other expenses?
Your response must be concise. 42.84. In the year 2002, what is the difference between the Expenses (% of total expenses) in Goods and services and Expenses (% of total expenses) in Subsidies and Transfers?
Offer a very short reply. -1.7. In the year 2002, what is the difference between the Expenses (% of total expenses) of Goods and services and Expenses (% of total expenses) of Other expenses?
Offer a very short reply. 21.27. In the year 2002, what is the difference between the Expenses (% of total expenses) of Subsidies and Transfers and Expenses (% of total expenses) of Other expenses?
Make the answer very short. 22.98. In the year 2003, what is the difference between the Expenses (% of total expenses) in Compensation of employees and Expenses (% of total expenses) in Goods and services?
Provide a succinct answer. 18.83. In the year 2003, what is the difference between the Expenses (% of total expenses) of Compensation of employees and Expenses (% of total expenses) of Subsidies and Transfers?
Give a very brief answer. 18.86. In the year 2003, what is the difference between the Expenses (% of total expenses) in Compensation of employees and Expenses (% of total expenses) in Other expenses?
Offer a very short reply. 41.71. In the year 2003, what is the difference between the Expenses (% of total expenses) of Goods and services and Expenses (% of total expenses) of Other expenses?
Offer a terse response. 22.88. In the year 2003, what is the difference between the Expenses (% of total expenses) in Subsidies and Transfers and Expenses (% of total expenses) in Other expenses?
Your answer should be very brief. 22.85. What is the ratio of the Expenses (% of total expenses) of Compensation of employees in 1997 to that in 1998?
Provide a succinct answer. 0.98. What is the ratio of the Expenses (% of total expenses) of Goods and services in 1997 to that in 1998?
Provide a succinct answer. 0.97. What is the ratio of the Expenses (% of total expenses) in Subsidies and Transfers in 1997 to that in 1998?
Your response must be concise. 1.16. What is the ratio of the Expenses (% of total expenses) of Other expenses in 1997 to that in 1998?
Provide a short and direct response. 0.97. What is the ratio of the Expenses (% of total expenses) in Compensation of employees in 1997 to that in 1999?
Keep it short and to the point. 1.08. What is the ratio of the Expenses (% of total expenses) of Goods and services in 1997 to that in 1999?
Offer a terse response. 1.01. What is the ratio of the Expenses (% of total expenses) of Subsidies and Transfers in 1997 to that in 1999?
Your response must be concise. 0.72. What is the ratio of the Expenses (% of total expenses) in Other expenses in 1997 to that in 1999?
Offer a terse response. 1.04. What is the ratio of the Expenses (% of total expenses) of Compensation of employees in 1997 to that in 2000?
Give a very brief answer. 1.21. What is the ratio of the Expenses (% of total expenses) in Goods and services in 1997 to that in 2000?
Give a very brief answer. 1.07. What is the ratio of the Expenses (% of total expenses) in Subsidies and Transfers in 1997 to that in 2000?
Make the answer very short. 0.52. What is the ratio of the Expenses (% of total expenses) in Other expenses in 1997 to that in 2000?
Make the answer very short. 0.34. What is the ratio of the Expenses (% of total expenses) in Compensation of employees in 1997 to that in 2001?
Give a very brief answer. 1.2. What is the ratio of the Expenses (% of total expenses) in Goods and services in 1997 to that in 2001?
Provide a short and direct response. 1.02. What is the ratio of the Expenses (% of total expenses) in Subsidies and Transfers in 1997 to that in 2001?
Your answer should be very brief. 0.56. What is the ratio of the Expenses (% of total expenses) of Other expenses in 1997 to that in 2001?
Ensure brevity in your answer.  0.65. What is the ratio of the Expenses (% of total expenses) in Compensation of employees in 1997 to that in 2002?
Make the answer very short. 1.19. What is the ratio of the Expenses (% of total expenses) of Subsidies and Transfers in 1997 to that in 2002?
Ensure brevity in your answer.  0.56. What is the ratio of the Expenses (% of total expenses) in Other expenses in 1997 to that in 2002?
Provide a succinct answer. 0.42. What is the ratio of the Expenses (% of total expenses) of Compensation of employees in 1997 to that in 2003?
Give a very brief answer. 1.22. What is the ratio of the Expenses (% of total expenses) of Goods and services in 1997 to that in 2003?
Ensure brevity in your answer.  0.93. What is the ratio of the Expenses (% of total expenses) of Subsidies and Transfers in 1997 to that in 2003?
Keep it short and to the point. 0.57. What is the ratio of the Expenses (% of total expenses) in Other expenses in 1997 to that in 2003?
Make the answer very short. 0.52. What is the ratio of the Expenses (% of total expenses) of Compensation of employees in 1998 to that in 1999?
Your response must be concise. 1.1. What is the ratio of the Expenses (% of total expenses) of Goods and services in 1998 to that in 1999?
Your answer should be compact. 1.04. What is the ratio of the Expenses (% of total expenses) in Subsidies and Transfers in 1998 to that in 1999?
Your response must be concise. 0.62. What is the ratio of the Expenses (% of total expenses) in Other expenses in 1998 to that in 1999?
Offer a terse response. 1.06. What is the ratio of the Expenses (% of total expenses) in Compensation of employees in 1998 to that in 2000?
Your answer should be very brief. 1.23. What is the ratio of the Expenses (% of total expenses) of Goods and services in 1998 to that in 2000?
Your answer should be very brief. 1.1. What is the ratio of the Expenses (% of total expenses) in Subsidies and Transfers in 1998 to that in 2000?
Provide a succinct answer. 0.45. What is the ratio of the Expenses (% of total expenses) in Other expenses in 1998 to that in 2000?
Offer a terse response. 0.35. What is the ratio of the Expenses (% of total expenses) of Compensation of employees in 1998 to that in 2001?
Offer a very short reply. 1.22. What is the ratio of the Expenses (% of total expenses) of Goods and services in 1998 to that in 2001?
Ensure brevity in your answer.  1.05. What is the ratio of the Expenses (% of total expenses) in Subsidies and Transfers in 1998 to that in 2001?
Give a very brief answer. 0.48. What is the ratio of the Expenses (% of total expenses) of Other expenses in 1998 to that in 2001?
Offer a terse response. 0.66. What is the ratio of the Expenses (% of total expenses) of Compensation of employees in 1998 to that in 2002?
Give a very brief answer. 1.21. What is the ratio of the Expenses (% of total expenses) of Goods and services in 1998 to that in 2002?
Provide a short and direct response. 1.02. What is the ratio of the Expenses (% of total expenses) in Subsidies and Transfers in 1998 to that in 2002?
Ensure brevity in your answer.  0.49. What is the ratio of the Expenses (% of total expenses) of Other expenses in 1998 to that in 2002?
Your answer should be very brief. 0.43. What is the ratio of the Expenses (% of total expenses) of Compensation of employees in 1998 to that in 2003?
Make the answer very short. 1.24. What is the ratio of the Expenses (% of total expenses) in Goods and services in 1998 to that in 2003?
Your answer should be compact. 0.96. What is the ratio of the Expenses (% of total expenses) of Subsidies and Transfers in 1998 to that in 2003?
Provide a succinct answer. 0.49. What is the ratio of the Expenses (% of total expenses) of Other expenses in 1998 to that in 2003?
Keep it short and to the point. 0.53. What is the ratio of the Expenses (% of total expenses) of Compensation of employees in 1999 to that in 2000?
Give a very brief answer. 1.12. What is the ratio of the Expenses (% of total expenses) in Goods and services in 1999 to that in 2000?
Offer a terse response. 1.06. What is the ratio of the Expenses (% of total expenses) in Subsidies and Transfers in 1999 to that in 2000?
Provide a short and direct response. 0.72. What is the ratio of the Expenses (% of total expenses) of Other expenses in 1999 to that in 2000?
Your response must be concise. 0.33. What is the ratio of the Expenses (% of total expenses) of Compensation of employees in 1999 to that in 2001?
Provide a succinct answer. 1.11. What is the ratio of the Expenses (% of total expenses) of Goods and services in 1999 to that in 2001?
Ensure brevity in your answer.  1.01. What is the ratio of the Expenses (% of total expenses) in Subsidies and Transfers in 1999 to that in 2001?
Offer a very short reply. 0.77. What is the ratio of the Expenses (% of total expenses) in Compensation of employees in 1999 to that in 2002?
Offer a very short reply. 1.1. What is the ratio of the Expenses (% of total expenses) in Goods and services in 1999 to that in 2002?
Give a very brief answer. 0.98. What is the ratio of the Expenses (% of total expenses) in Subsidies and Transfers in 1999 to that in 2002?
Provide a short and direct response. 0.78. What is the ratio of the Expenses (% of total expenses) in Other expenses in 1999 to that in 2002?
Offer a very short reply. 0.41. What is the ratio of the Expenses (% of total expenses) in Compensation of employees in 1999 to that in 2003?
Make the answer very short. 1.13. What is the ratio of the Expenses (% of total expenses) of Goods and services in 1999 to that in 2003?
Give a very brief answer. 0.92. What is the ratio of the Expenses (% of total expenses) of Subsidies and Transfers in 1999 to that in 2003?
Offer a very short reply. 0.79. What is the ratio of the Expenses (% of total expenses) in Other expenses in 1999 to that in 2003?
Your response must be concise. 0.5. What is the ratio of the Expenses (% of total expenses) in Compensation of employees in 2000 to that in 2001?
Provide a short and direct response. 0.99. What is the ratio of the Expenses (% of total expenses) of Goods and services in 2000 to that in 2001?
Ensure brevity in your answer.  0.95. What is the ratio of the Expenses (% of total expenses) of Subsidies and Transfers in 2000 to that in 2001?
Your answer should be compact. 1.07. What is the ratio of the Expenses (% of total expenses) of Other expenses in 2000 to that in 2001?
Provide a succinct answer. 1.88. What is the ratio of the Expenses (% of total expenses) of Compensation of employees in 2000 to that in 2002?
Your answer should be compact. 0.98. What is the ratio of the Expenses (% of total expenses) of Goods and services in 2000 to that in 2002?
Give a very brief answer. 0.93. What is the ratio of the Expenses (% of total expenses) in Subsidies and Transfers in 2000 to that in 2002?
Provide a succinct answer. 1.08. What is the ratio of the Expenses (% of total expenses) of Other expenses in 2000 to that in 2002?
Keep it short and to the point. 1.23. What is the ratio of the Expenses (% of total expenses) of Compensation of employees in 2000 to that in 2003?
Offer a very short reply. 1.01. What is the ratio of the Expenses (% of total expenses) in Goods and services in 2000 to that in 2003?
Ensure brevity in your answer.  0.87. What is the ratio of the Expenses (% of total expenses) in Subsidies and Transfers in 2000 to that in 2003?
Your answer should be very brief. 1.09. What is the ratio of the Expenses (% of total expenses) of Other expenses in 2000 to that in 2003?
Keep it short and to the point. 1.51. What is the ratio of the Expenses (% of total expenses) of Subsidies and Transfers in 2001 to that in 2002?
Keep it short and to the point. 1.01. What is the ratio of the Expenses (% of total expenses) in Other expenses in 2001 to that in 2002?
Offer a terse response. 0.65. What is the ratio of the Expenses (% of total expenses) of Goods and services in 2001 to that in 2003?
Provide a short and direct response. 0.91. What is the ratio of the Expenses (% of total expenses) of Subsidies and Transfers in 2001 to that in 2003?
Offer a very short reply. 1.02. What is the ratio of the Expenses (% of total expenses) of Other expenses in 2001 to that in 2003?
Your response must be concise. 0.8. What is the ratio of the Expenses (% of total expenses) of Compensation of employees in 2002 to that in 2003?
Give a very brief answer. 1.03. What is the ratio of the Expenses (% of total expenses) in Goods and services in 2002 to that in 2003?
Keep it short and to the point. 0.94. What is the ratio of the Expenses (% of total expenses) of Subsidies and Transfers in 2002 to that in 2003?
Your answer should be compact. 1.01. What is the ratio of the Expenses (% of total expenses) in Other expenses in 2002 to that in 2003?
Give a very brief answer. 1.22. What is the difference between the highest and the second highest Expenses (% of total expenses) in Compensation of employees?
Your response must be concise. 0.9. What is the difference between the highest and the second highest Expenses (% of total expenses) of Goods and services?
Ensure brevity in your answer.  1.04. What is the difference between the highest and the second highest Expenses (% of total expenses) of Subsidies and Transfers?
Offer a very short reply. 1.63. What is the difference between the highest and the second highest Expenses (% of total expenses) in Other expenses?
Your answer should be compact. 0.13. What is the difference between the highest and the lowest Expenses (% of total expenses) of Compensation of employees?
Offer a terse response. 10.29. What is the difference between the highest and the lowest Expenses (% of total expenses) of Goods and services?
Your answer should be very brief. 3.12. What is the difference between the highest and the lowest Expenses (% of total expenses) in Subsidies and Transfers?
Your answer should be compact. 13.95. What is the difference between the highest and the lowest Expenses (% of total expenses) in Other expenses?
Offer a terse response. 0.46. 